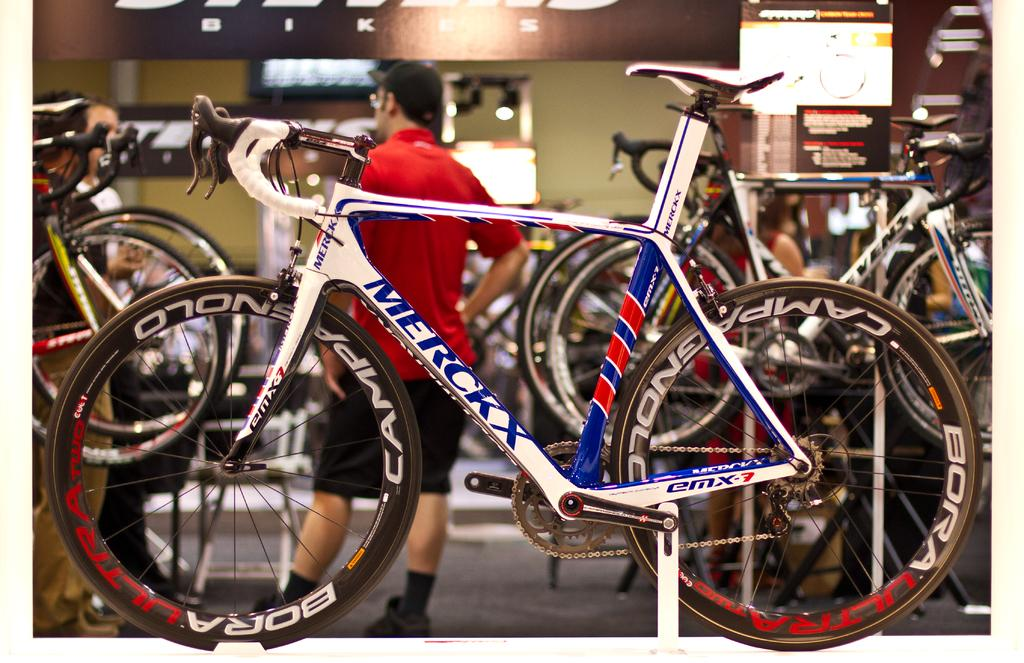What type of vehicles are in the image? There are bicycles in the image. What else can be seen in the image besides the bicycles? There is a group of people standing in the image, as well as boards and other objects. What type of song is being sung by the oranges in the image? There are no oranges present in the image, and therefore no singing can be observed. 